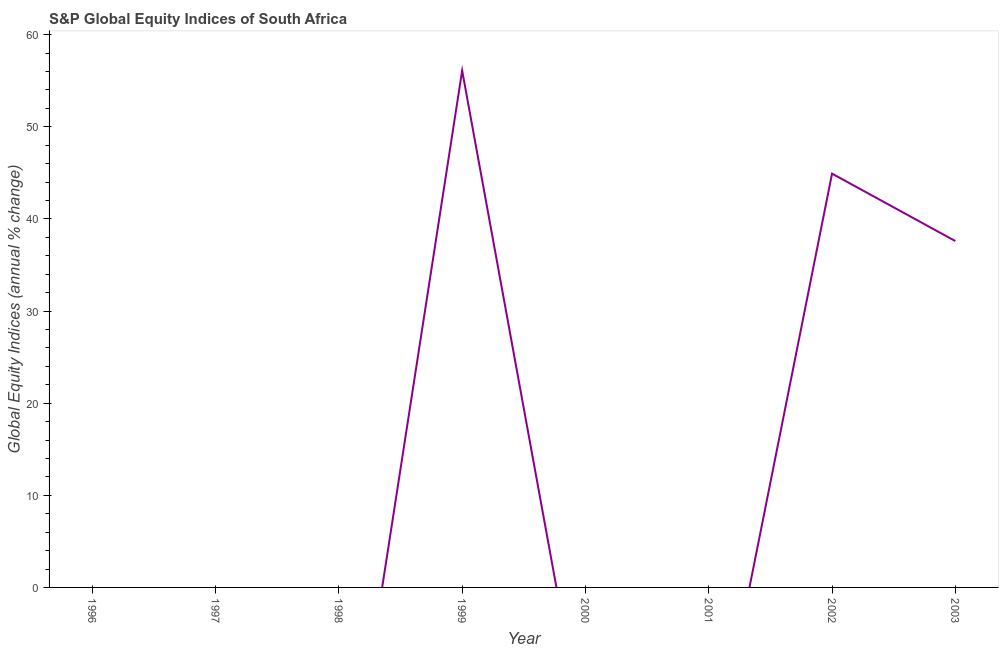Across all years, what is the maximum s&p global equity indices?
Your answer should be compact. 56.1. What is the sum of the s&p global equity indices?
Your answer should be very brief. 138.62. What is the average s&p global equity indices per year?
Provide a short and direct response. 17.33. What is the ratio of the s&p global equity indices in 2002 to that in 2003?
Provide a short and direct response. 1.19. What is the difference between the highest and the second highest s&p global equity indices?
Your answer should be very brief. 11.18. What is the difference between the highest and the lowest s&p global equity indices?
Provide a short and direct response. 56.1. In how many years, is the s&p global equity indices greater than the average s&p global equity indices taken over all years?
Make the answer very short. 3. Does the s&p global equity indices monotonically increase over the years?
Your answer should be very brief. No. What is the title of the graph?
Give a very brief answer. S&P Global Equity Indices of South Africa. What is the label or title of the X-axis?
Provide a succinct answer. Year. What is the label or title of the Y-axis?
Your response must be concise. Global Equity Indices (annual % change). What is the Global Equity Indices (annual % change) of 1996?
Offer a very short reply. 0. What is the Global Equity Indices (annual % change) in 1997?
Your answer should be compact. 0. What is the Global Equity Indices (annual % change) in 1999?
Make the answer very short. 56.1. What is the Global Equity Indices (annual % change) in 2001?
Keep it short and to the point. 0. What is the Global Equity Indices (annual % change) of 2002?
Your answer should be compact. 44.92. What is the Global Equity Indices (annual % change) of 2003?
Make the answer very short. 37.6. What is the difference between the Global Equity Indices (annual % change) in 1999 and 2002?
Keep it short and to the point. 11.18. What is the difference between the Global Equity Indices (annual % change) in 1999 and 2003?
Your answer should be very brief. 18.5. What is the difference between the Global Equity Indices (annual % change) in 2002 and 2003?
Provide a succinct answer. 7.32. What is the ratio of the Global Equity Indices (annual % change) in 1999 to that in 2002?
Offer a very short reply. 1.25. What is the ratio of the Global Equity Indices (annual % change) in 1999 to that in 2003?
Your response must be concise. 1.49. What is the ratio of the Global Equity Indices (annual % change) in 2002 to that in 2003?
Offer a terse response. 1.2. 